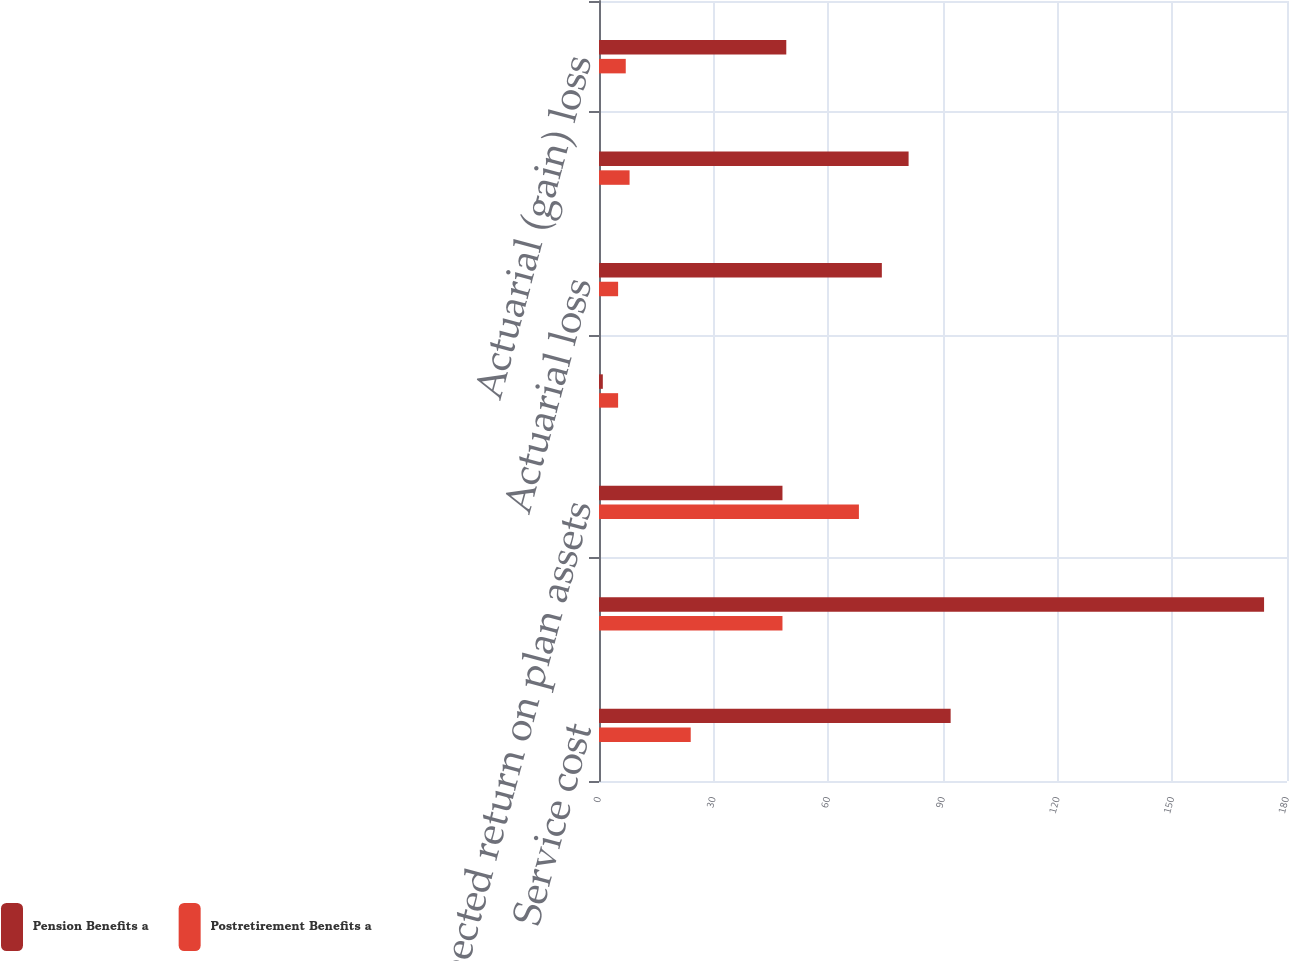<chart> <loc_0><loc_0><loc_500><loc_500><stacked_bar_chart><ecel><fcel>Service cost<fcel>Interest cost<fcel>Expected return on plan assets<fcel>Prior service credit<fcel>Actuarial loss<fcel>Net periodic benefit cost<fcel>Actuarial (gain) loss<nl><fcel>Pension Benefits a<fcel>92<fcel>174<fcel>48<fcel>1<fcel>74<fcel>81<fcel>49<nl><fcel>Postretirement Benefits a<fcel>24<fcel>48<fcel>68<fcel>5<fcel>5<fcel>8<fcel>7<nl></chart> 